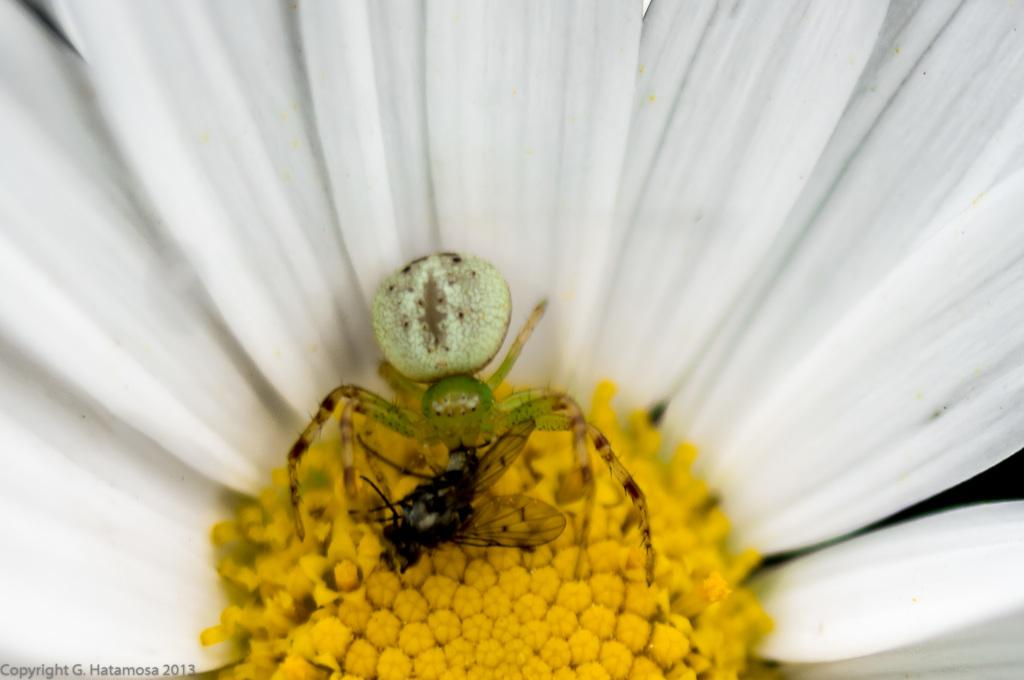What type of flower is in the image? There is a white and yellow flower in the image. Are there any insects on the flower? Yes, a spider and a housefly are present on the flower. Where is the watermark located in the image? The watermark is on the bottom left side of the image. What grade did the hand receive for pushing the flower in the image? There is no hand present in the image, nor is there any indication of a grade or pushing action. 